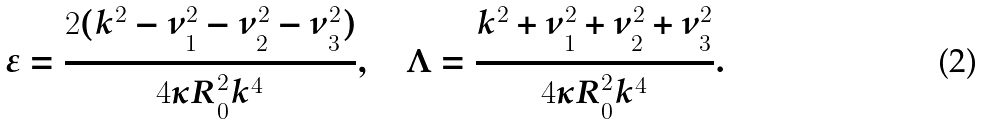Convert formula to latex. <formula><loc_0><loc_0><loc_500><loc_500>\varepsilon = { \frac { 2 ( k ^ { 2 } - \nu _ { 1 } ^ { 2 } - \nu _ { 2 } ^ { 2 } - \nu _ { 3 } ^ { 2 } ) } { 4 \kappa R _ { 0 } ^ { 2 } k ^ { 4 } } } , \quad \Lambda = { \frac { k ^ { 2 } + \nu _ { 1 } ^ { 2 } + \nu _ { 2 } ^ { 2 } + \nu _ { 3 } ^ { 2 } } { 4 \kappa R _ { 0 } ^ { 2 } k ^ { 4 } } } .</formula> 